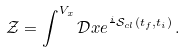Convert formula to latex. <formula><loc_0><loc_0><loc_500><loc_500>\mathcal { Z } = \int ^ { V _ { x } } \mathcal { D } x e ^ { \frac { i } { } \mathcal { S } _ { c l } ( t _ { f } , t _ { i } ) } \, .</formula> 